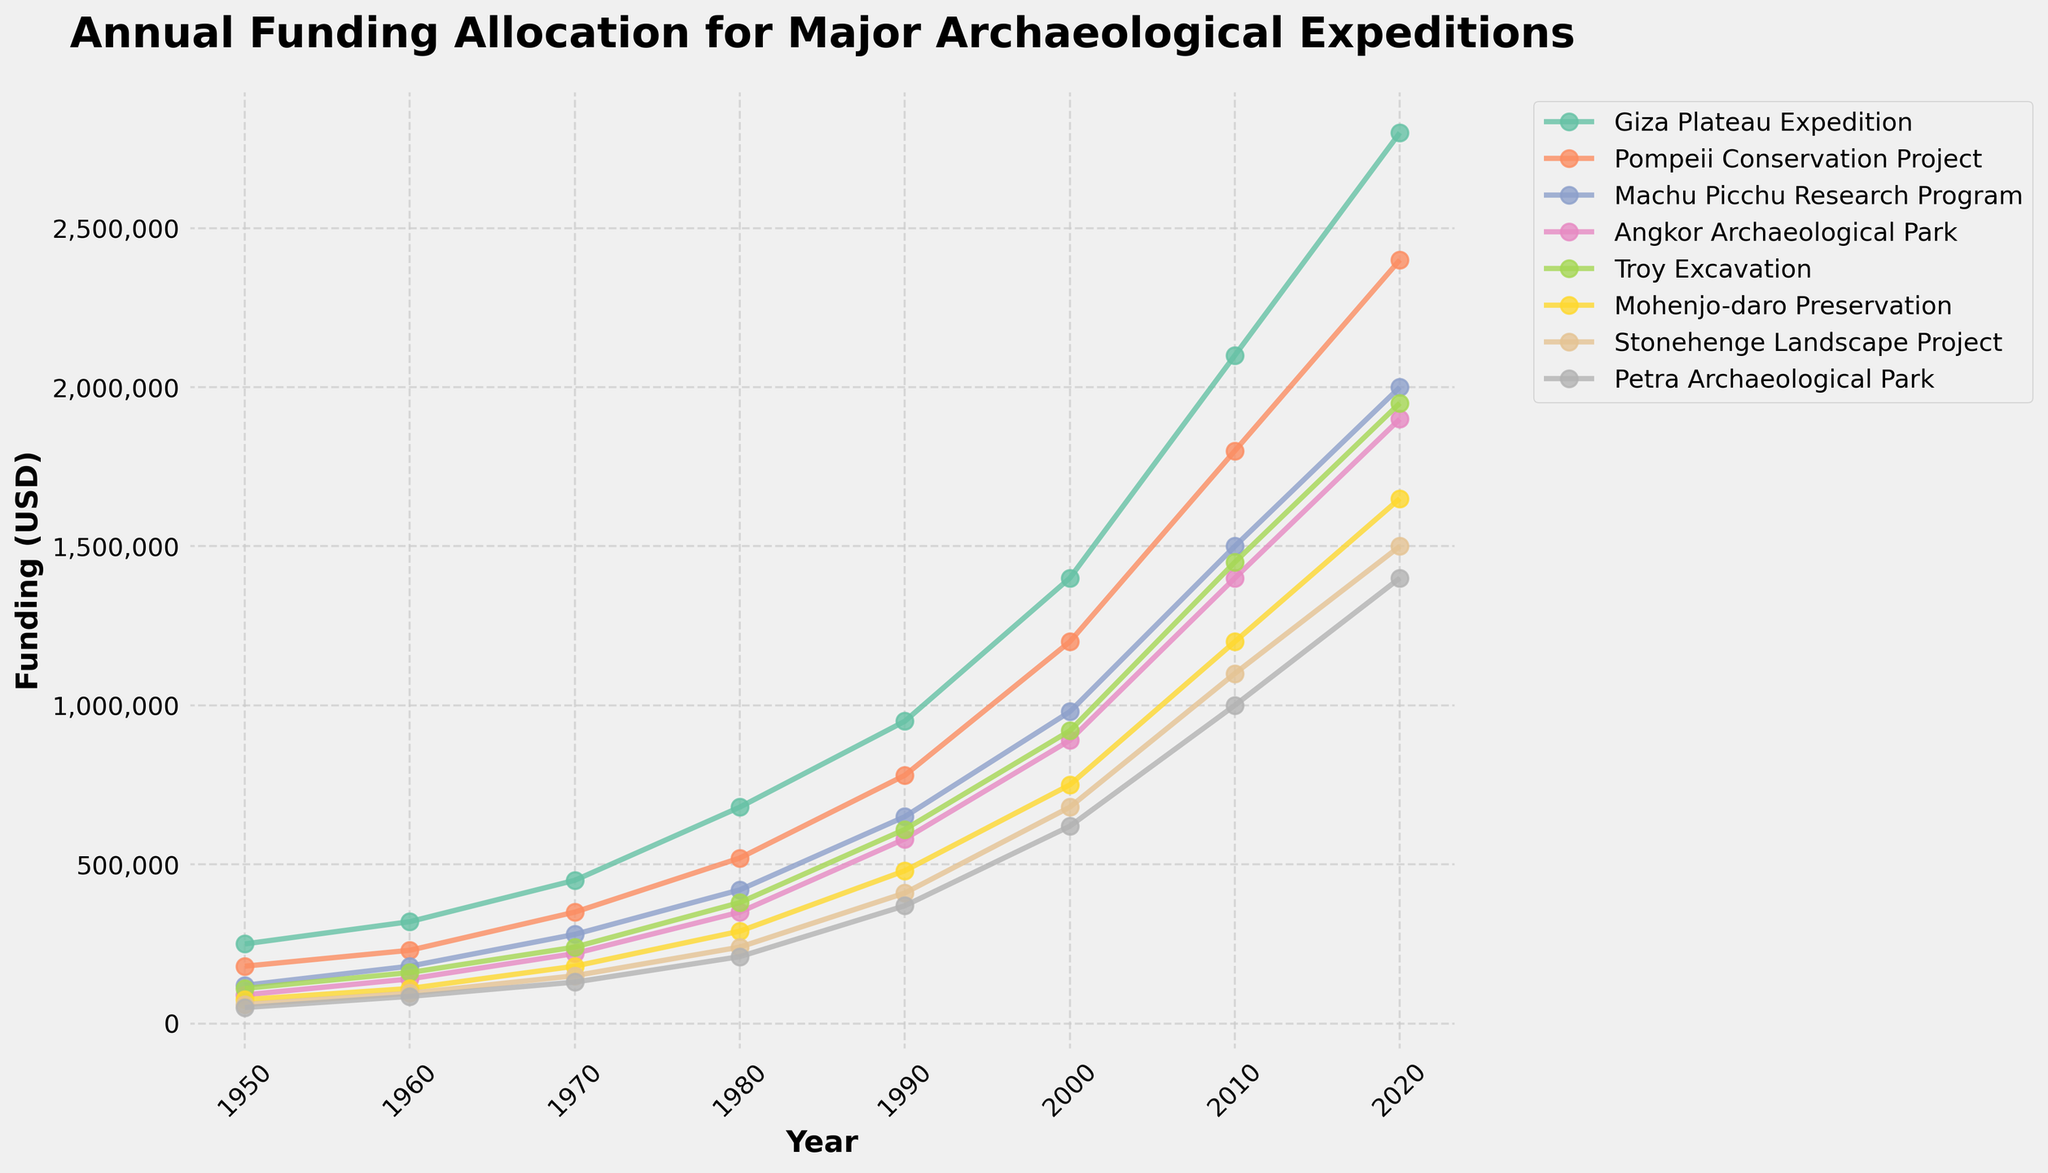What is the difference in funding between the Giza Plateau Expedition and the Pompeii Conservation Project in 1980? Look at the 1980 data points: Giza Plateau Expedition has $680,000 and Pompeii Conservation Project has $520,000. The difference is $680,000 - $520,000
Answer: $160,000 Which expedition received the highest funding in 2020? Refer to the 2020 data points and compare the values across all expeditions. The Giza Plateau Expedition received the highest funding with $2,800,000
Answer: Giza Plateau Expedition How much did the funding for the Machu Picchu Research Program increase from 1950 to 2000? Check the funding in 1950 and 2000 for the Machu Picchu Research Program: $120,000 in 1950 and $980,000 in 2000. The increase is $980,000 - $120,000
Answer: $860,000 What is the average funding for the Stonehenge Landscape Project over all the years provided? Add the funding amounts for the Stonehenge Landscape Project from each year and then divide by the number of years (8): (60,000 + 95,000 + 150,000 + 240,000 + 410,000 + 680,000 + 1,100,000 + 1,500,000)/8
Answer: $529,375 Which expedition showed the most significant percentage increase in funding from 1950 to 2020? Calculate the percentage increase for each expedition from 1950 to 2020 using the formula: ((Funding in 2020 - Funding in 1950) / Funding in 1950) * 100. Identify the highest percentage. For Giza Plateau Expedition: ((2,800,000 - 250,000)/250,000) * 100 = 1020%, for Pompeii Conservation Project: ((2,400,000 - 180,000)/180,000) * 100 = 1233%, for Machu Picchu Research Program: ((2,000,000 - 120,000)/120,000) * 100 = 1567%, for Angkor Archaeological Park: ((1,900,000 - 90,000)/90,000) * 100 = 2011%, for Troy Excavation: ((1,950,000 - 110,000)/110,000) * 100 = 1673%, for Mohenjo-daro Preservation: ((1,650,000 - 75,000)/75,000) * 100 = 2100%, for Stonehenge Landscape Project: ((1,500,000 - 60,000)/60,000) * 100 = 2400%, for Petra Archaeological Park: ((1,400,000 - 50,000)/50,000) * 100 = 2700%. The most significant percentage increase is for Petra Archaeological Park
Answer: Petra Archaeological Park How does the funding trend for the Angkor Archaeological Park from 1950 to 2020 compare to that of the Giza Plateau Expedition? Observe the funding lines for both expeditions over the years. Both lines show an increasing trend, but the Giza Plateau Expedition consistently has higher absolute funding and steeper increases over time compared to Angkor Archaeological Park.
Answer: Giza Plateau Expedition has higher funding What is the total combined funding for all expeditions in the year 1990? Sum the funding amounts for all expeditions in 1990: 950,000 (Giza Plateau Expedition) + 780,000 (Pompeii Conservation Project) + 650,000 (Machu Picchu Research Program) + 580,000 (Angkor Archaeological Park) + 610,000 (Troy Excavation) + 480,000 (Mohenjo-daro Preservation) + 410,000 (Stonehenge Landscape Project) + 370,000 (Petra Archaeological Park)
Answer: $4,830,000 Which expedition had the smallest funding increase between 2000 and 2010? Calculate funding difference from 2000 to 2010 for each expedition: (Giza Plateau Expedition: 2,100,000 - 1,400,000 = 700,000), (Pompeii Conservation Project: 1,800,000 - 1,200,000 = 600,000), (Machu Picchu Research Program: 1,500,000 - 980,000 = 520,000), (Angkor Archaeological Park: 1,400,000 - 890,000 = 510,000), (Troy Excavation: 1,450,000 - 920,000 = 530,000), (Mohenjo-daro Preservation: 1,200,000 - 750,000 = 450,000), (Stonehenge Landscape Project: 1,100,000 - 680,000 = 420,000), (Petra Archaeological Park: 1,000,000 - 620,000 = 380,000). The smallest increase was for Petra Archaeological Park
Answer: Petra Archaeological Park 